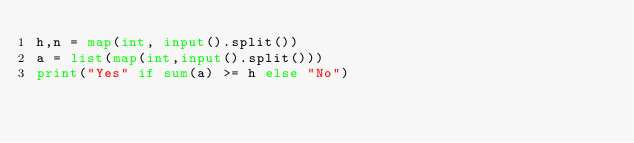<code> <loc_0><loc_0><loc_500><loc_500><_Python_>h,n = map(int, input().split())
a = list(map(int,input().split()))
print("Yes" if sum(a) >= h else "No")</code> 